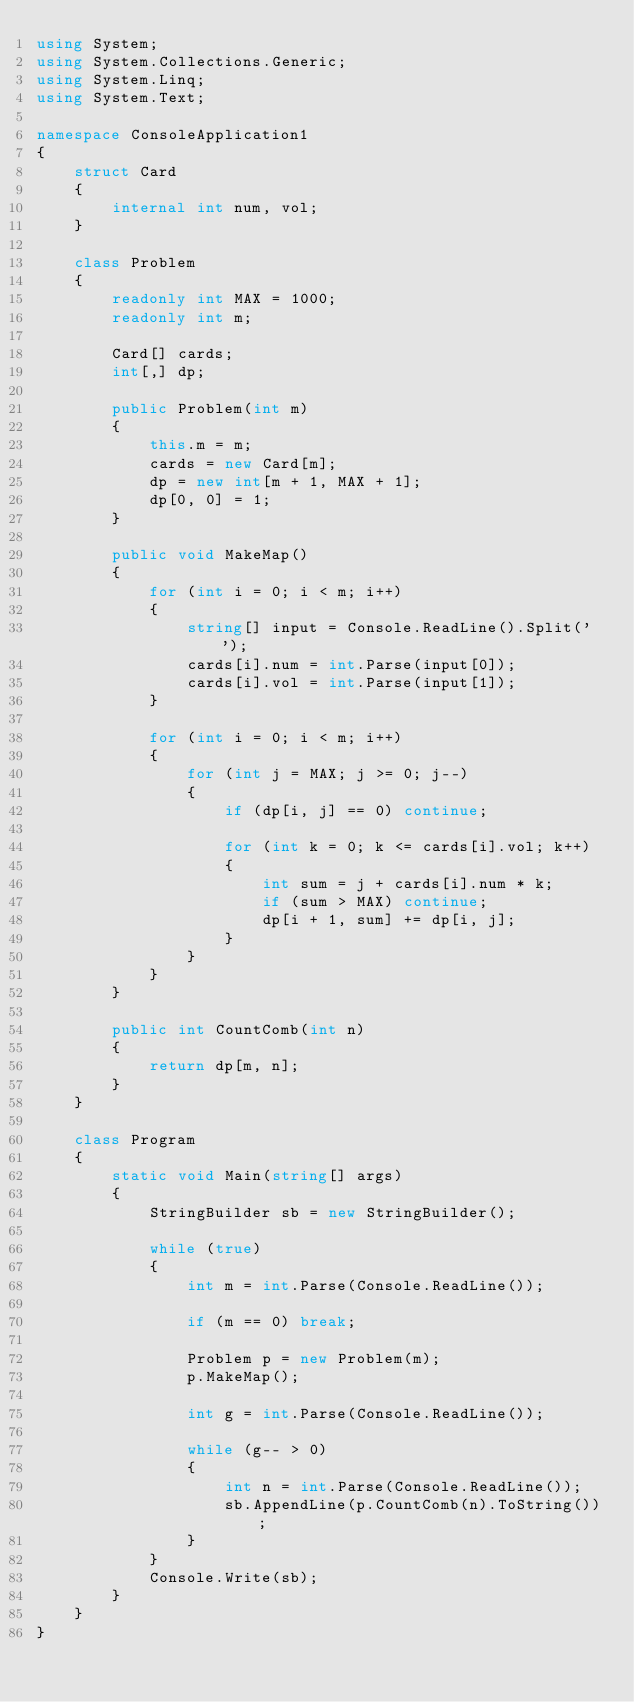<code> <loc_0><loc_0><loc_500><loc_500><_C#_>using System;
using System.Collections.Generic;
using System.Linq;
using System.Text;

namespace ConsoleApplication1
{
    struct Card
    {
        internal int num, vol;
    }

    class Problem
    {
        readonly int MAX = 1000;
        readonly int m;

        Card[] cards;
        int[,] dp;

        public Problem(int m)
        {
            this.m = m;
            cards = new Card[m];
            dp = new int[m + 1, MAX + 1];
            dp[0, 0] = 1;
        }

        public void MakeMap()
        {
            for (int i = 0; i < m; i++)
            {
                string[] input = Console.ReadLine().Split(' ');
                cards[i].num = int.Parse(input[0]);
                cards[i].vol = int.Parse(input[1]);
            }

            for (int i = 0; i < m; i++)
            {
                for (int j = MAX; j >= 0; j--)
                {
                    if (dp[i, j] == 0) continue;

                    for (int k = 0; k <= cards[i].vol; k++)
                    {
                        int sum = j + cards[i].num * k;
                        if (sum > MAX) continue;
                        dp[i + 1, sum] += dp[i, j];
                    }
                }
            }
        }

        public int CountComb(int n)
        {
            return dp[m, n];
        }
    }

    class Program
    {
        static void Main(string[] args)
        {
            StringBuilder sb = new StringBuilder();

            while (true)
            {
                int m = int.Parse(Console.ReadLine());

                if (m == 0) break;

                Problem p = new Problem(m);
                p.MakeMap();

                int g = int.Parse(Console.ReadLine());

                while (g-- > 0)
                {
                    int n = int.Parse(Console.ReadLine());
                    sb.AppendLine(p.CountComb(n).ToString());
                }
            }
            Console.Write(sb);
        }
    }
}</code> 